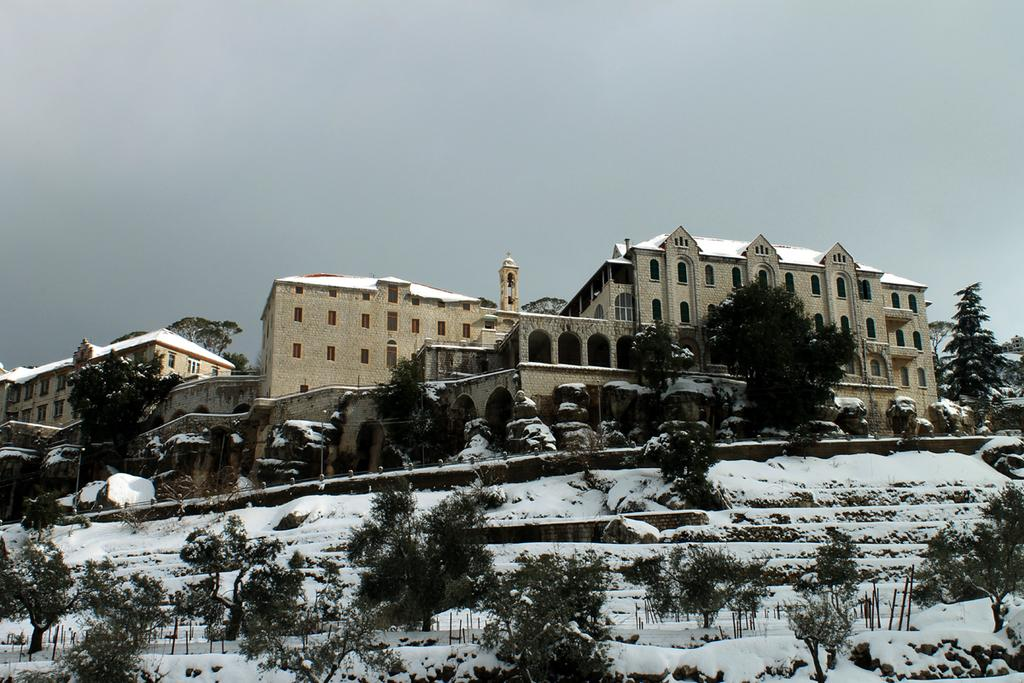What is located in the center of the picture? There are trees, stones, and buildings in the center of the picture. What can be seen in the foreground of the picture? There are trees, poles, and snow in the foreground of the picture. What is the condition of the sky in the image? The sky is cloudy in the image. How does the fog affect the visibility of the mine in the image? There is no mine present in the image, and the sky is cloudy, not foggy. What is the digestion process of the trees in the image? Trees do not have a digestion process; they are plants that produce their own food through photosynthesis. 